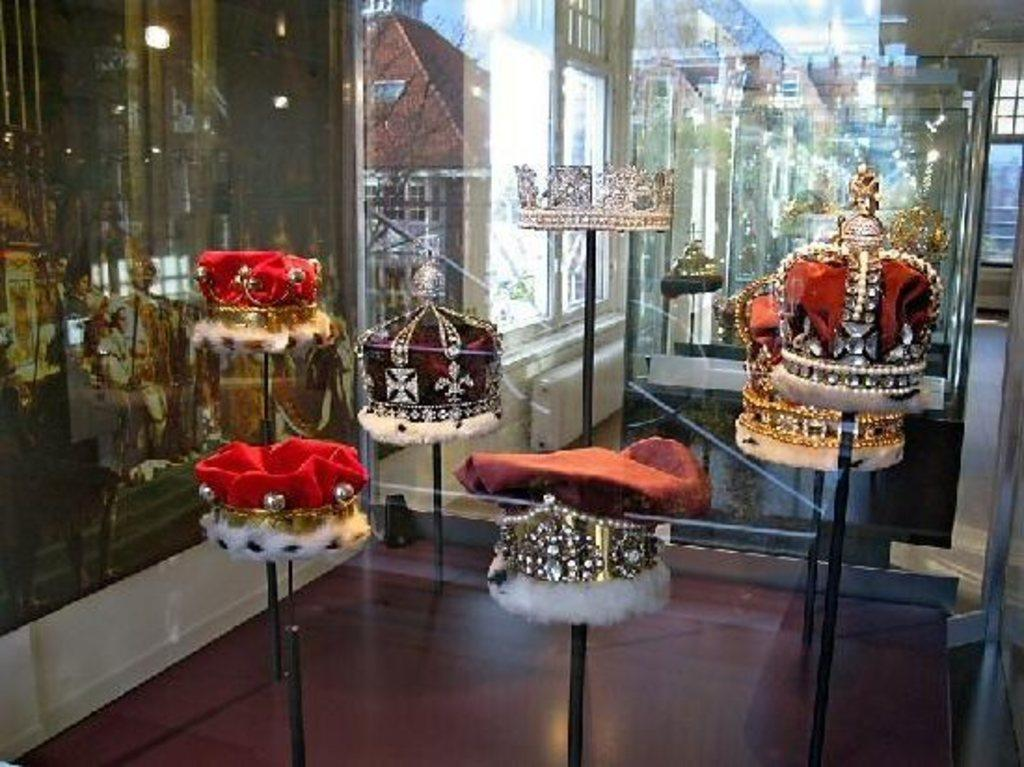What objects are on poles in the front of the image? There are hats on poles in the front of the image. What can be seen in the background of the image? There is a glass in the background of the image. What is visible on the glass? There are reflections on the glass. What type of lock is securing the airport in the image? There is no airport or lock present in the image; it features hats on poles and a glass with reflections. 